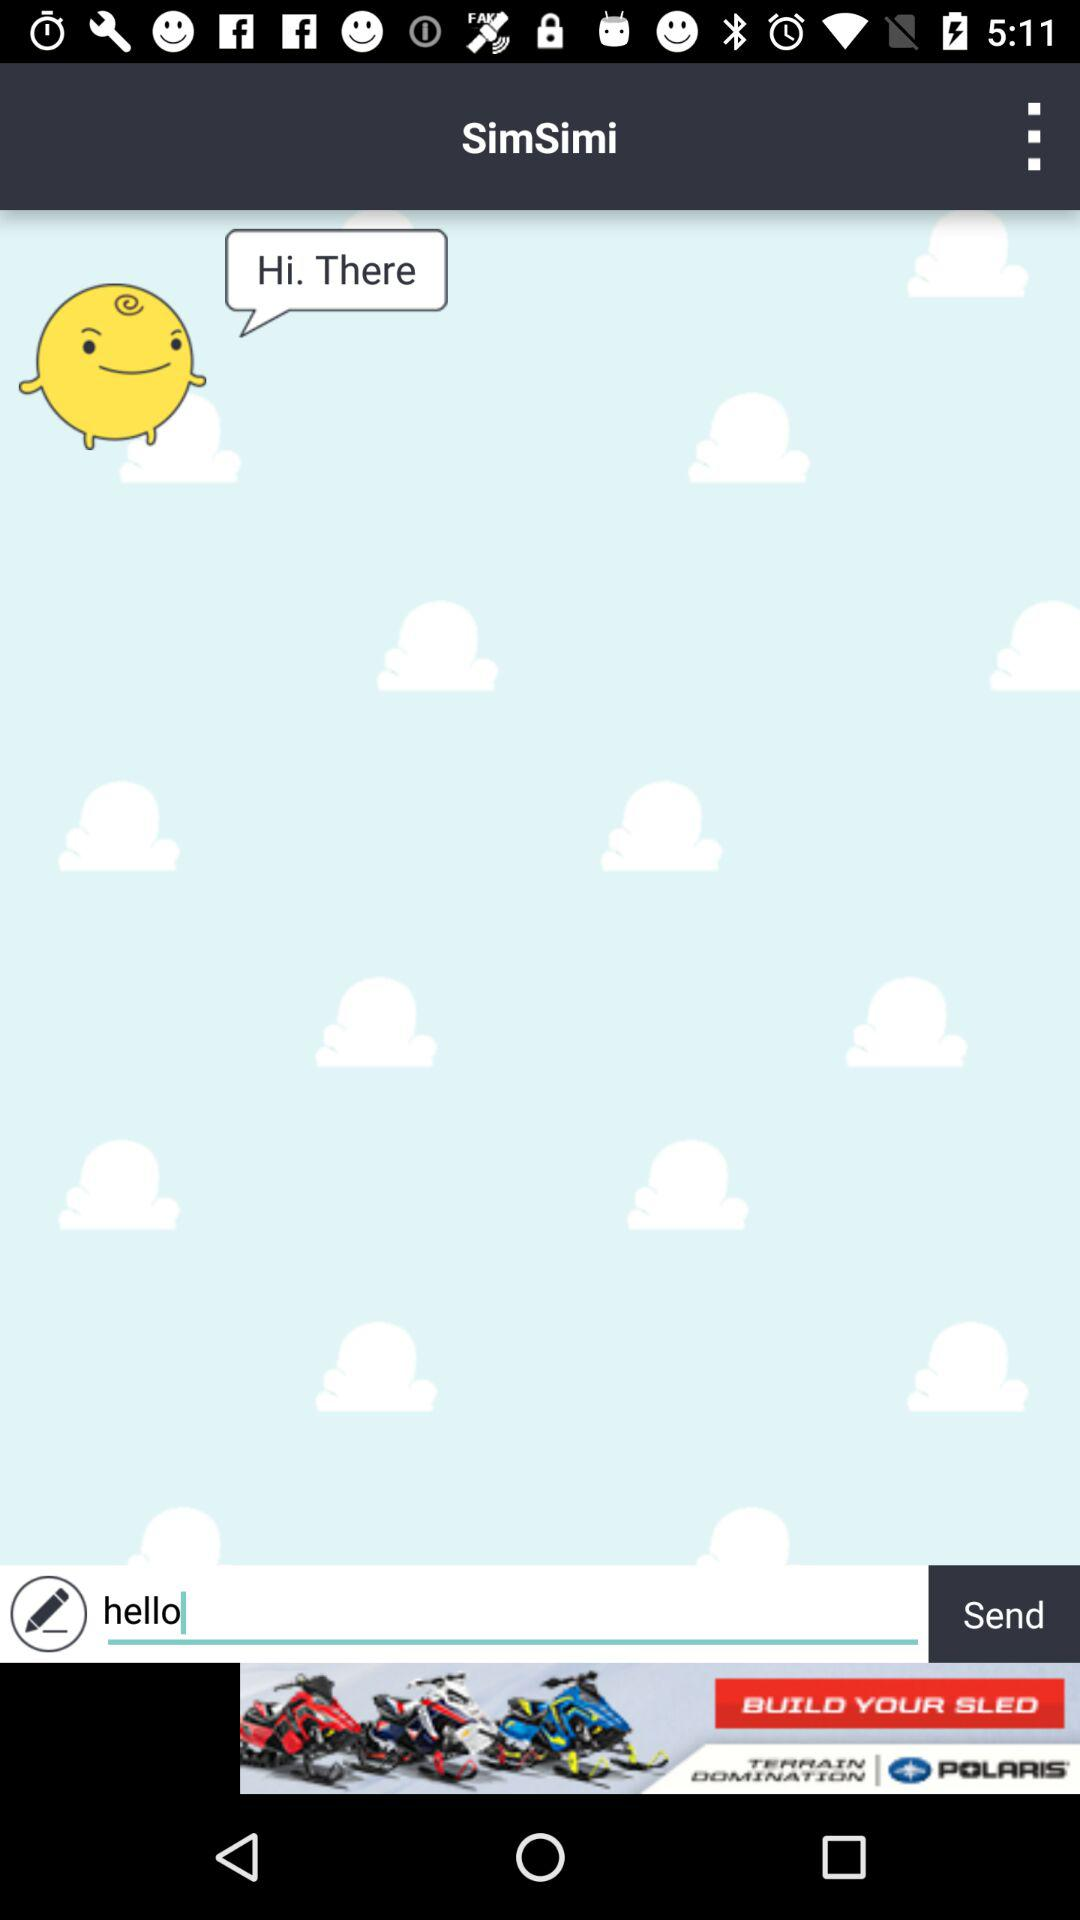What is the name of the user?
When the provided information is insufficient, respond with <no answer>. <no answer> 